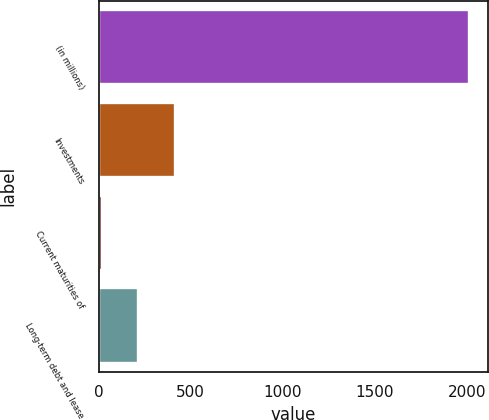Convert chart. <chart><loc_0><loc_0><loc_500><loc_500><bar_chart><fcel>(in millions)<fcel>Investments<fcel>Current maturities of<fcel>Long-term debt and lease<nl><fcel>2011<fcel>415<fcel>16<fcel>215.5<nl></chart> 